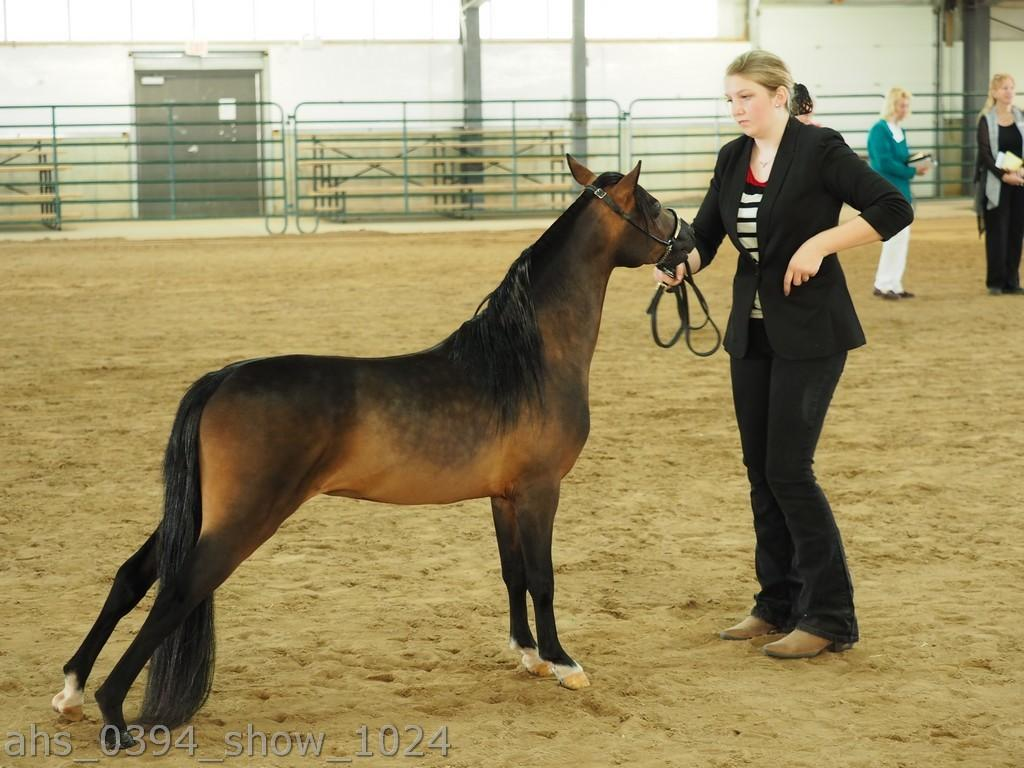Who is the main subject in the image? There is a woman in the image. What is the woman wearing? The woman is wearing a suit. What is in front of the woman? There is a horse in front of the woman. Are there any other people in the image? Yes, there are people standing far from the woman and the horse. What type of bean can be seen floating in the water near the woman and the horse? There is no bean present in the image, and no water is visible either. 